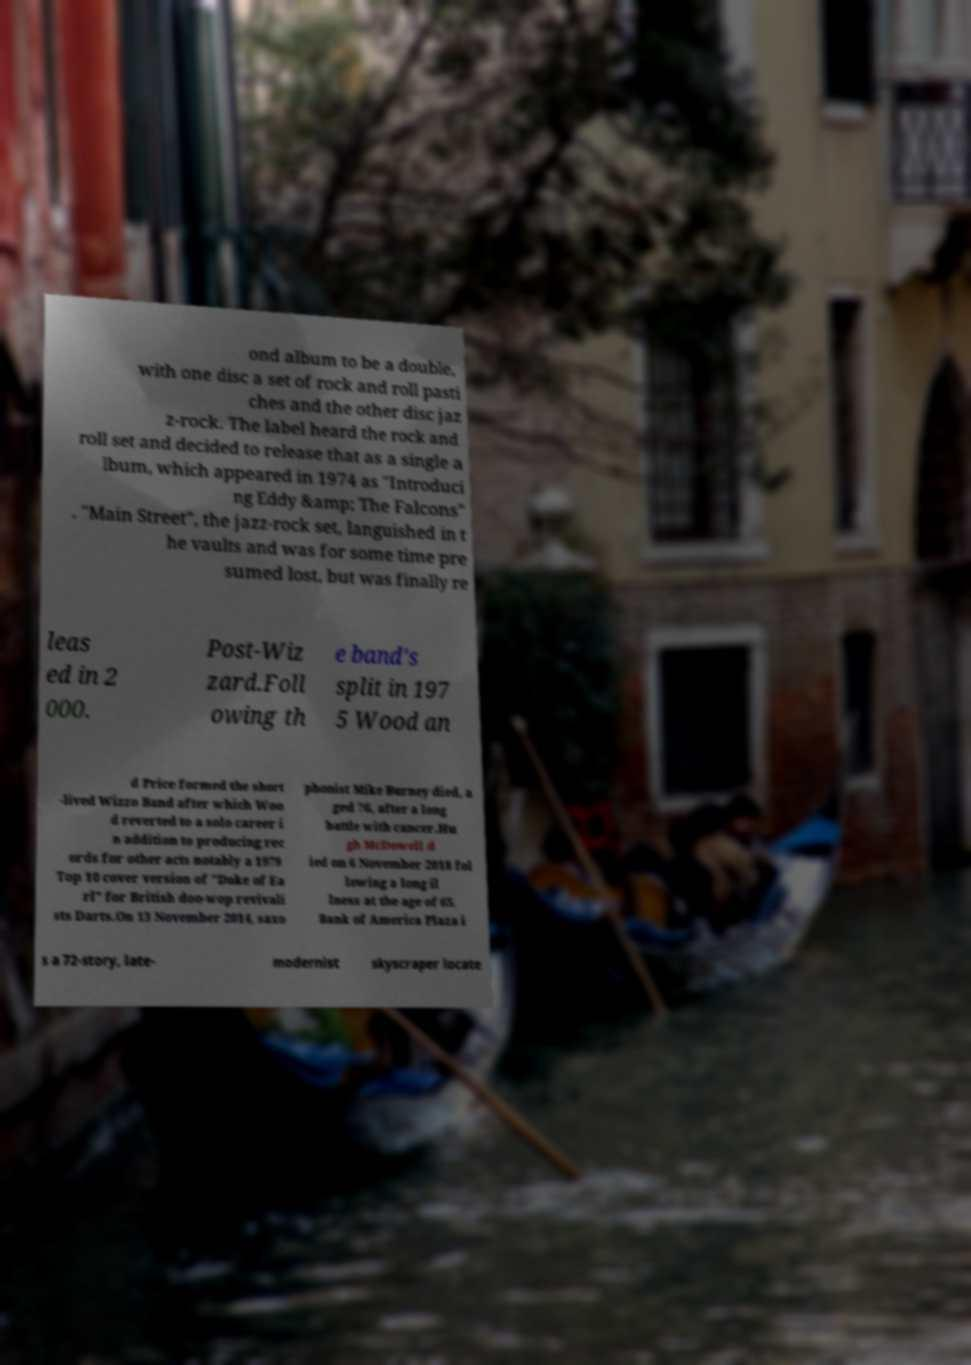Can you accurately transcribe the text from the provided image for me? ond album to be a double, with one disc a set of rock and roll pasti ches and the other disc jaz z-rock. The label heard the rock and roll set and decided to release that as a single a lbum, which appeared in 1974 as "Introduci ng Eddy &amp; The Falcons" . "Main Street", the jazz-rock set, languished in t he vaults and was for some time pre sumed lost, but was finally re leas ed in 2 000. Post-Wiz zard.Foll owing th e band's split in 197 5 Wood an d Price formed the short -lived Wizzo Band after which Woo d reverted to a solo career i n addition to producing rec ords for other acts notably a 1979 Top 10 cover version of "Duke of Ea rl" for British doo-wop revivali sts Darts.On 13 November 2014, saxo phonist Mike Burney died, a ged 76, after a long battle with cancer.Hu gh McDowell d ied on 6 November 2018 fol lowing a long il lness at the age of 65. Bank of America Plaza i s a 72-story, late- modernist skyscraper locate 